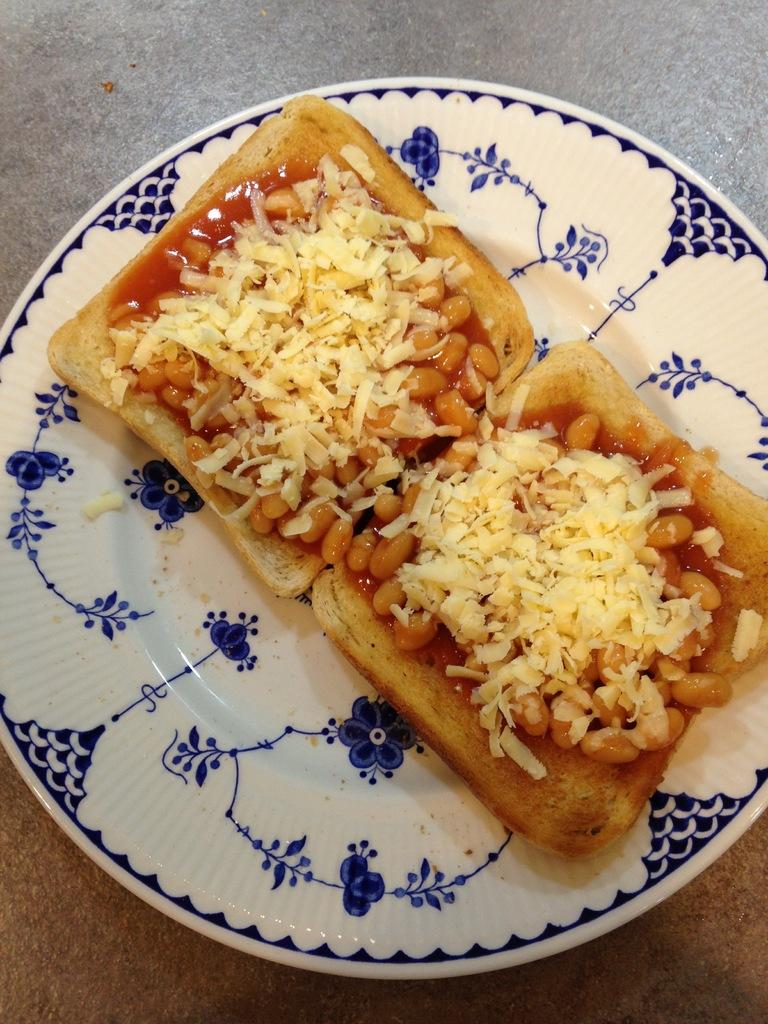What is the color of the plate in the image? The plate in the image is white. What decorations are on the plate? The plate has designs of flowers. What food items are on the plate? There are breads on the plate. What is on top of the breads? There are brown and cream-colored things on the breads. What direction does the paste flow on the breads in the image? There is no paste present in the image, so it is not possible to determine the direction of its flow. 